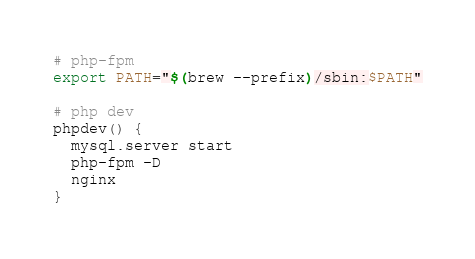<code> <loc_0><loc_0><loc_500><loc_500><_Bash_># php-fpm
export PATH="$(brew --prefix)/sbin:$PATH"

# php dev
phpdev() {
  mysql.server start
  php-fpm -D
  nginx
}
</code> 